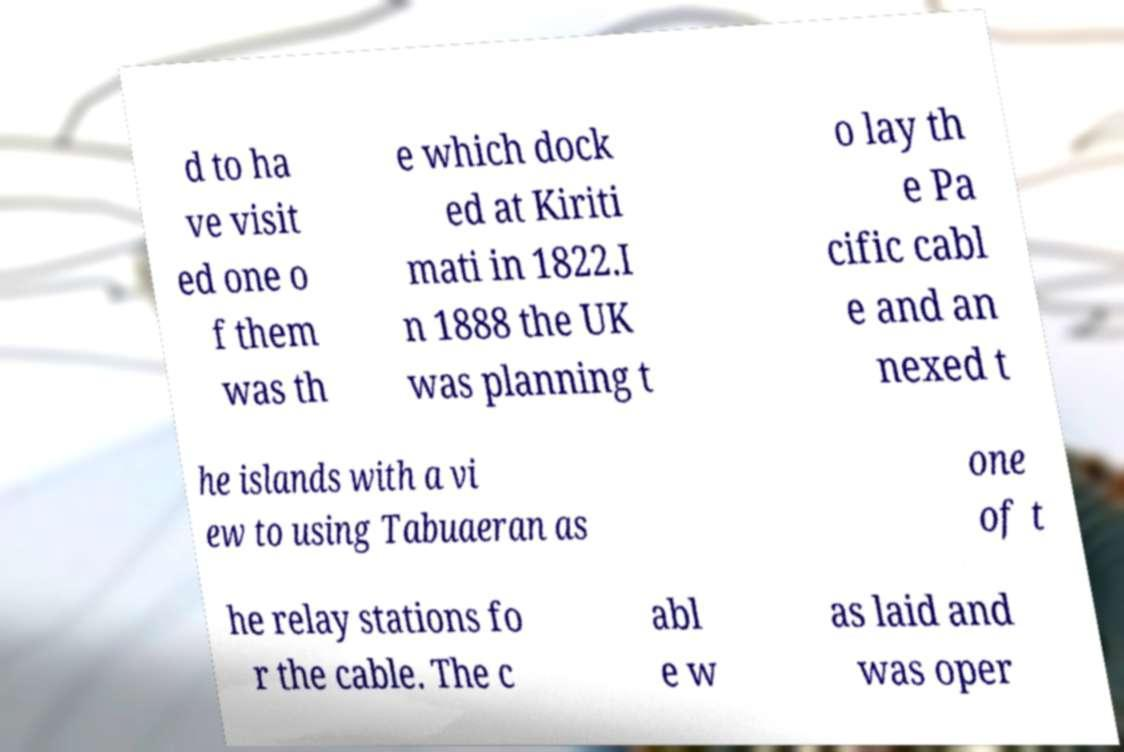I need the written content from this picture converted into text. Can you do that? d to ha ve visit ed one o f them was th e which dock ed at Kiriti mati in 1822.I n 1888 the UK was planning t o lay th e Pa cific cabl e and an nexed t he islands with a vi ew to using Tabuaeran as one of t he relay stations fo r the cable. The c abl e w as laid and was oper 